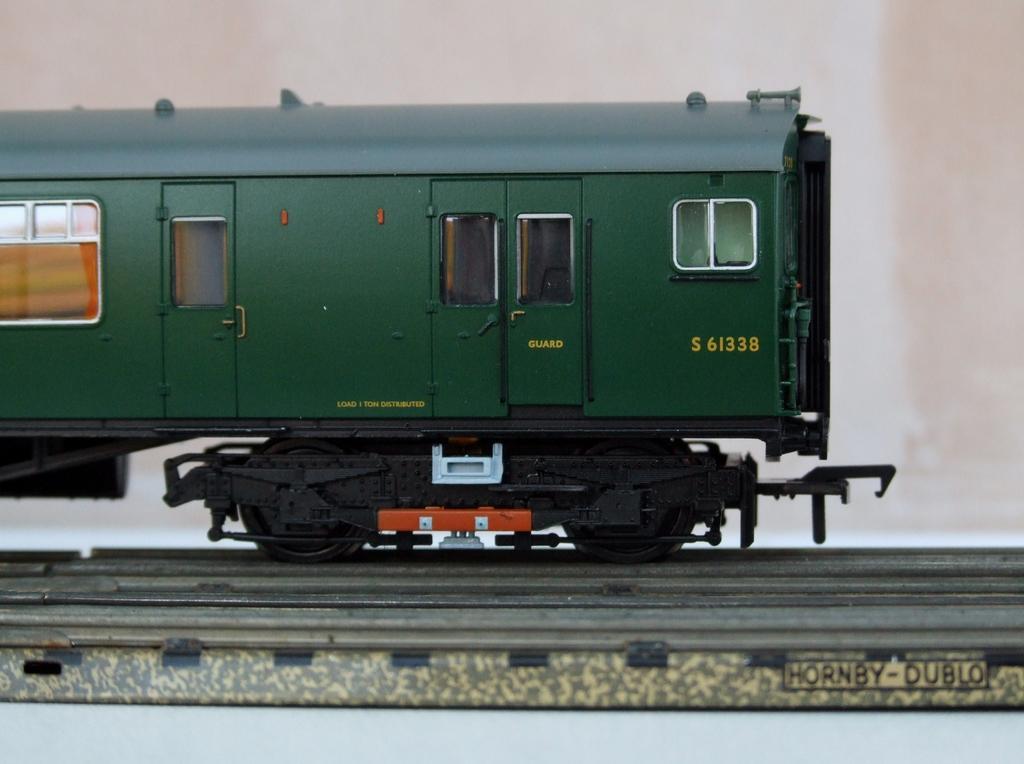Could you give a brief overview of what you see in this image? It's a miniature, this is the train. It is in green color. 